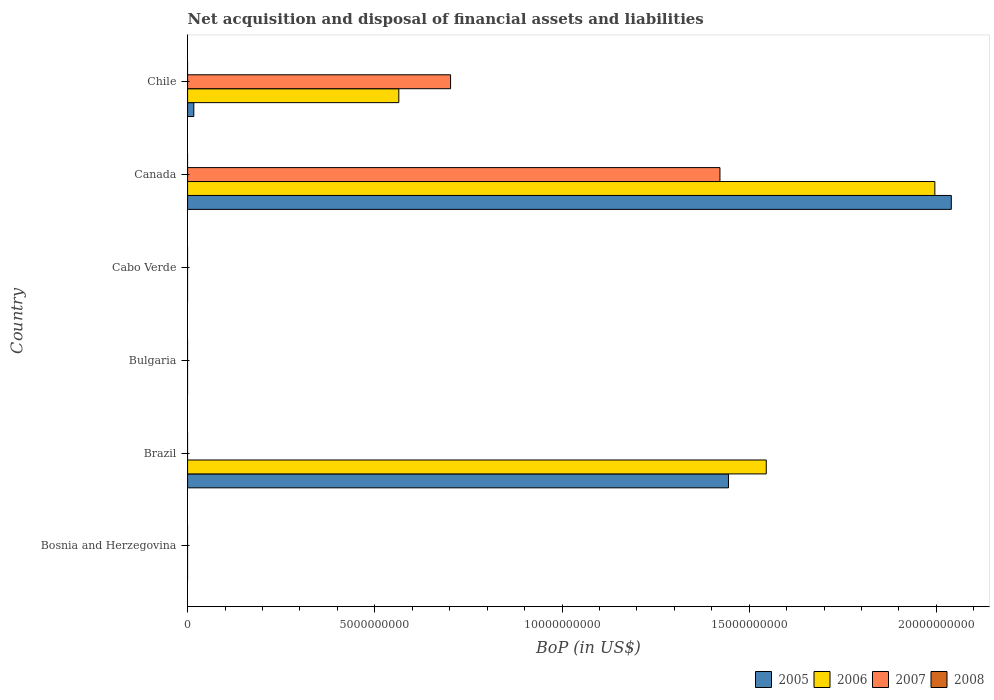How many different coloured bars are there?
Ensure brevity in your answer.  3. Are the number of bars per tick equal to the number of legend labels?
Your response must be concise. No. Are the number of bars on each tick of the Y-axis equal?
Provide a succinct answer. No. How many bars are there on the 1st tick from the top?
Give a very brief answer. 3. In how many cases, is the number of bars for a given country not equal to the number of legend labels?
Give a very brief answer. 6. What is the Balance of Payments in 2005 in Brazil?
Your answer should be compact. 1.44e+1. Across all countries, what is the maximum Balance of Payments in 2007?
Your answer should be very brief. 1.42e+1. Across all countries, what is the minimum Balance of Payments in 2005?
Keep it short and to the point. 0. What is the total Balance of Payments in 2007 in the graph?
Provide a succinct answer. 2.12e+1. What is the difference between the Balance of Payments in 2007 in Cabo Verde and the Balance of Payments in 2006 in Canada?
Provide a short and direct response. -2.00e+1. What is the average Balance of Payments in 2006 per country?
Your answer should be very brief. 6.84e+09. What is the difference between the Balance of Payments in 2006 and Balance of Payments in 2007 in Chile?
Your answer should be compact. -1.38e+09. In how many countries, is the Balance of Payments in 2005 greater than 18000000000 US$?
Ensure brevity in your answer.  1. What is the difference between the highest and the second highest Balance of Payments in 2005?
Ensure brevity in your answer.  5.95e+09. What is the difference between the highest and the lowest Balance of Payments in 2006?
Your response must be concise. 2.00e+1. Is it the case that in every country, the sum of the Balance of Payments in 2005 and Balance of Payments in 2008 is greater than the sum of Balance of Payments in 2007 and Balance of Payments in 2006?
Ensure brevity in your answer.  No. Where does the legend appear in the graph?
Your answer should be very brief. Bottom right. What is the title of the graph?
Provide a succinct answer. Net acquisition and disposal of financial assets and liabilities. Does "2012" appear as one of the legend labels in the graph?
Keep it short and to the point. No. What is the label or title of the X-axis?
Your answer should be compact. BoP (in US$). What is the BoP (in US$) in 2006 in Bosnia and Herzegovina?
Ensure brevity in your answer.  0. What is the BoP (in US$) in 2007 in Bosnia and Herzegovina?
Provide a short and direct response. 0. What is the BoP (in US$) of 2005 in Brazil?
Your answer should be compact. 1.44e+1. What is the BoP (in US$) in 2006 in Brazil?
Offer a terse response. 1.55e+1. What is the BoP (in US$) in 2007 in Brazil?
Your answer should be compact. 0. What is the BoP (in US$) of 2006 in Bulgaria?
Give a very brief answer. 0. What is the BoP (in US$) in 2007 in Bulgaria?
Give a very brief answer. 0. What is the BoP (in US$) in 2005 in Cabo Verde?
Keep it short and to the point. 0. What is the BoP (in US$) of 2007 in Cabo Verde?
Keep it short and to the point. 0. What is the BoP (in US$) of 2008 in Cabo Verde?
Provide a short and direct response. 0. What is the BoP (in US$) of 2005 in Canada?
Offer a terse response. 2.04e+1. What is the BoP (in US$) in 2006 in Canada?
Offer a very short reply. 2.00e+1. What is the BoP (in US$) in 2007 in Canada?
Your answer should be compact. 1.42e+1. What is the BoP (in US$) in 2008 in Canada?
Your response must be concise. 0. What is the BoP (in US$) in 2005 in Chile?
Keep it short and to the point. 1.66e+08. What is the BoP (in US$) in 2006 in Chile?
Your answer should be very brief. 5.64e+09. What is the BoP (in US$) of 2007 in Chile?
Provide a short and direct response. 7.02e+09. What is the BoP (in US$) of 2008 in Chile?
Your response must be concise. 0. Across all countries, what is the maximum BoP (in US$) in 2005?
Keep it short and to the point. 2.04e+1. Across all countries, what is the maximum BoP (in US$) in 2006?
Your answer should be very brief. 2.00e+1. Across all countries, what is the maximum BoP (in US$) of 2007?
Keep it short and to the point. 1.42e+1. Across all countries, what is the minimum BoP (in US$) in 2005?
Keep it short and to the point. 0. What is the total BoP (in US$) in 2005 in the graph?
Give a very brief answer. 3.50e+1. What is the total BoP (in US$) of 2006 in the graph?
Offer a very short reply. 4.11e+1. What is the total BoP (in US$) of 2007 in the graph?
Make the answer very short. 2.12e+1. What is the total BoP (in US$) of 2008 in the graph?
Offer a very short reply. 0. What is the difference between the BoP (in US$) of 2005 in Brazil and that in Canada?
Keep it short and to the point. -5.95e+09. What is the difference between the BoP (in US$) in 2006 in Brazil and that in Canada?
Your answer should be very brief. -4.50e+09. What is the difference between the BoP (in US$) in 2005 in Brazil and that in Chile?
Offer a terse response. 1.43e+1. What is the difference between the BoP (in US$) of 2006 in Brazil and that in Chile?
Give a very brief answer. 9.81e+09. What is the difference between the BoP (in US$) in 2005 in Canada and that in Chile?
Offer a very short reply. 2.02e+1. What is the difference between the BoP (in US$) in 2006 in Canada and that in Chile?
Provide a short and direct response. 1.43e+1. What is the difference between the BoP (in US$) in 2007 in Canada and that in Chile?
Your answer should be compact. 7.19e+09. What is the difference between the BoP (in US$) in 2005 in Brazil and the BoP (in US$) in 2006 in Canada?
Ensure brevity in your answer.  -5.51e+09. What is the difference between the BoP (in US$) in 2005 in Brazil and the BoP (in US$) in 2007 in Canada?
Make the answer very short. 2.27e+08. What is the difference between the BoP (in US$) in 2006 in Brazil and the BoP (in US$) in 2007 in Canada?
Offer a very short reply. 1.24e+09. What is the difference between the BoP (in US$) of 2005 in Brazil and the BoP (in US$) of 2006 in Chile?
Your answer should be very brief. 8.80e+09. What is the difference between the BoP (in US$) in 2005 in Brazil and the BoP (in US$) in 2007 in Chile?
Give a very brief answer. 7.42e+09. What is the difference between the BoP (in US$) of 2006 in Brazil and the BoP (in US$) of 2007 in Chile?
Provide a succinct answer. 8.43e+09. What is the difference between the BoP (in US$) of 2005 in Canada and the BoP (in US$) of 2006 in Chile?
Offer a very short reply. 1.48e+1. What is the difference between the BoP (in US$) of 2005 in Canada and the BoP (in US$) of 2007 in Chile?
Offer a terse response. 1.34e+1. What is the difference between the BoP (in US$) of 2006 in Canada and the BoP (in US$) of 2007 in Chile?
Your response must be concise. 1.29e+1. What is the average BoP (in US$) in 2005 per country?
Provide a short and direct response. 5.84e+09. What is the average BoP (in US$) in 2006 per country?
Give a very brief answer. 6.84e+09. What is the average BoP (in US$) in 2007 per country?
Your response must be concise. 3.54e+09. What is the difference between the BoP (in US$) of 2005 and BoP (in US$) of 2006 in Brazil?
Your answer should be very brief. -1.01e+09. What is the difference between the BoP (in US$) in 2005 and BoP (in US$) in 2006 in Canada?
Make the answer very short. 4.40e+08. What is the difference between the BoP (in US$) of 2005 and BoP (in US$) of 2007 in Canada?
Ensure brevity in your answer.  6.18e+09. What is the difference between the BoP (in US$) in 2006 and BoP (in US$) in 2007 in Canada?
Your answer should be compact. 5.74e+09. What is the difference between the BoP (in US$) of 2005 and BoP (in US$) of 2006 in Chile?
Your answer should be compact. -5.48e+09. What is the difference between the BoP (in US$) of 2005 and BoP (in US$) of 2007 in Chile?
Keep it short and to the point. -6.86e+09. What is the difference between the BoP (in US$) of 2006 and BoP (in US$) of 2007 in Chile?
Make the answer very short. -1.38e+09. What is the ratio of the BoP (in US$) of 2005 in Brazil to that in Canada?
Offer a terse response. 0.71. What is the ratio of the BoP (in US$) of 2006 in Brazil to that in Canada?
Make the answer very short. 0.77. What is the ratio of the BoP (in US$) of 2005 in Brazil to that in Chile?
Provide a short and direct response. 86.98. What is the ratio of the BoP (in US$) of 2006 in Brazil to that in Chile?
Your response must be concise. 2.74. What is the ratio of the BoP (in US$) of 2005 in Canada to that in Chile?
Give a very brief answer. 122.81. What is the ratio of the BoP (in US$) in 2006 in Canada to that in Chile?
Your response must be concise. 3.54. What is the ratio of the BoP (in US$) in 2007 in Canada to that in Chile?
Make the answer very short. 2.02. What is the difference between the highest and the second highest BoP (in US$) of 2005?
Ensure brevity in your answer.  5.95e+09. What is the difference between the highest and the second highest BoP (in US$) of 2006?
Provide a short and direct response. 4.50e+09. What is the difference between the highest and the lowest BoP (in US$) of 2005?
Offer a terse response. 2.04e+1. What is the difference between the highest and the lowest BoP (in US$) in 2006?
Your answer should be very brief. 2.00e+1. What is the difference between the highest and the lowest BoP (in US$) in 2007?
Offer a terse response. 1.42e+1. 